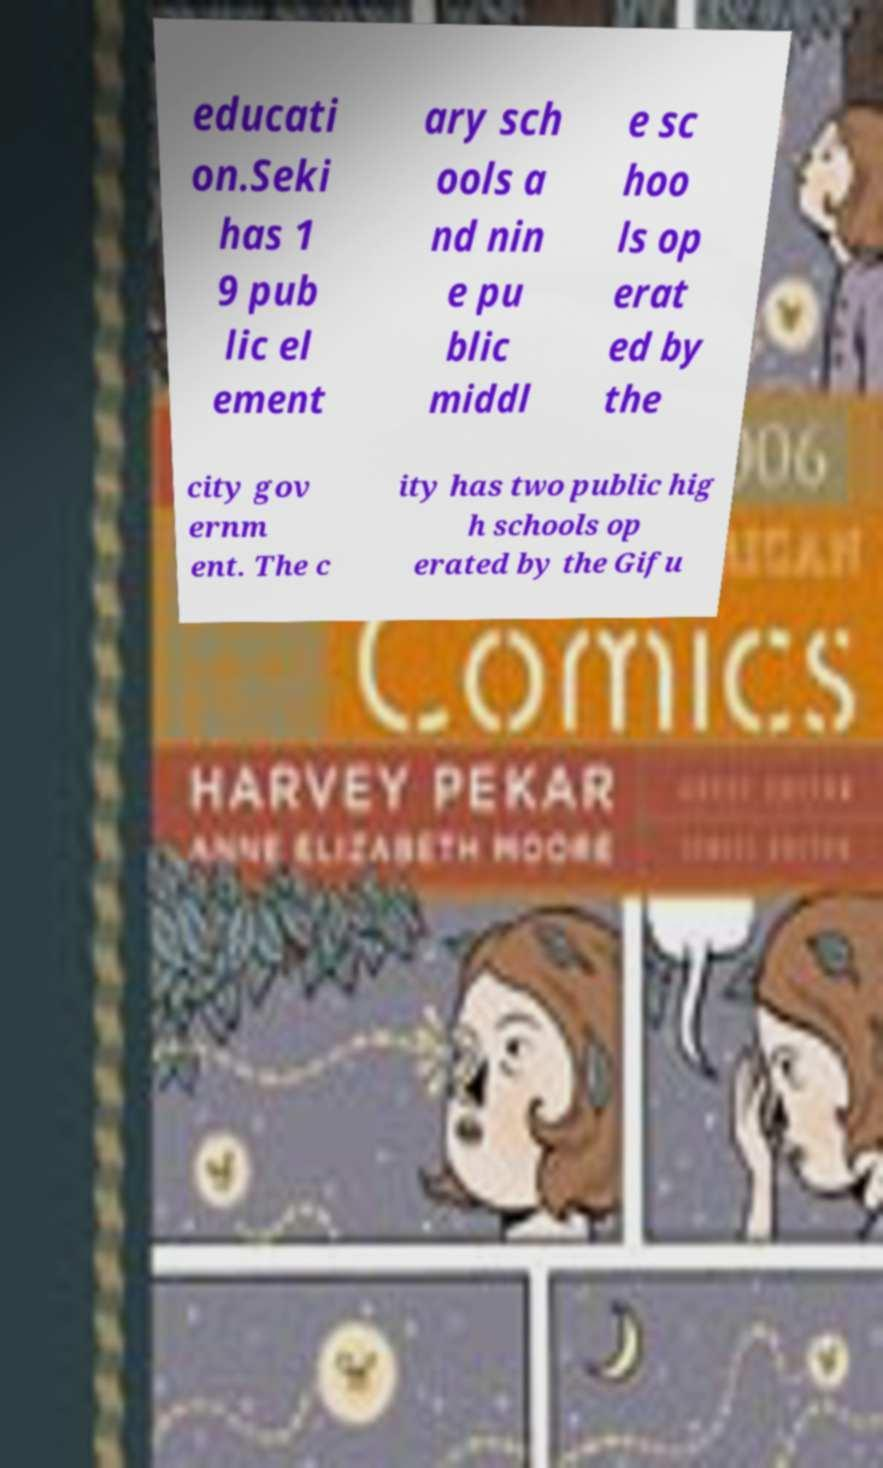For documentation purposes, I need the text within this image transcribed. Could you provide that? educati on.Seki has 1 9 pub lic el ement ary sch ools a nd nin e pu blic middl e sc hoo ls op erat ed by the city gov ernm ent. The c ity has two public hig h schools op erated by the Gifu 